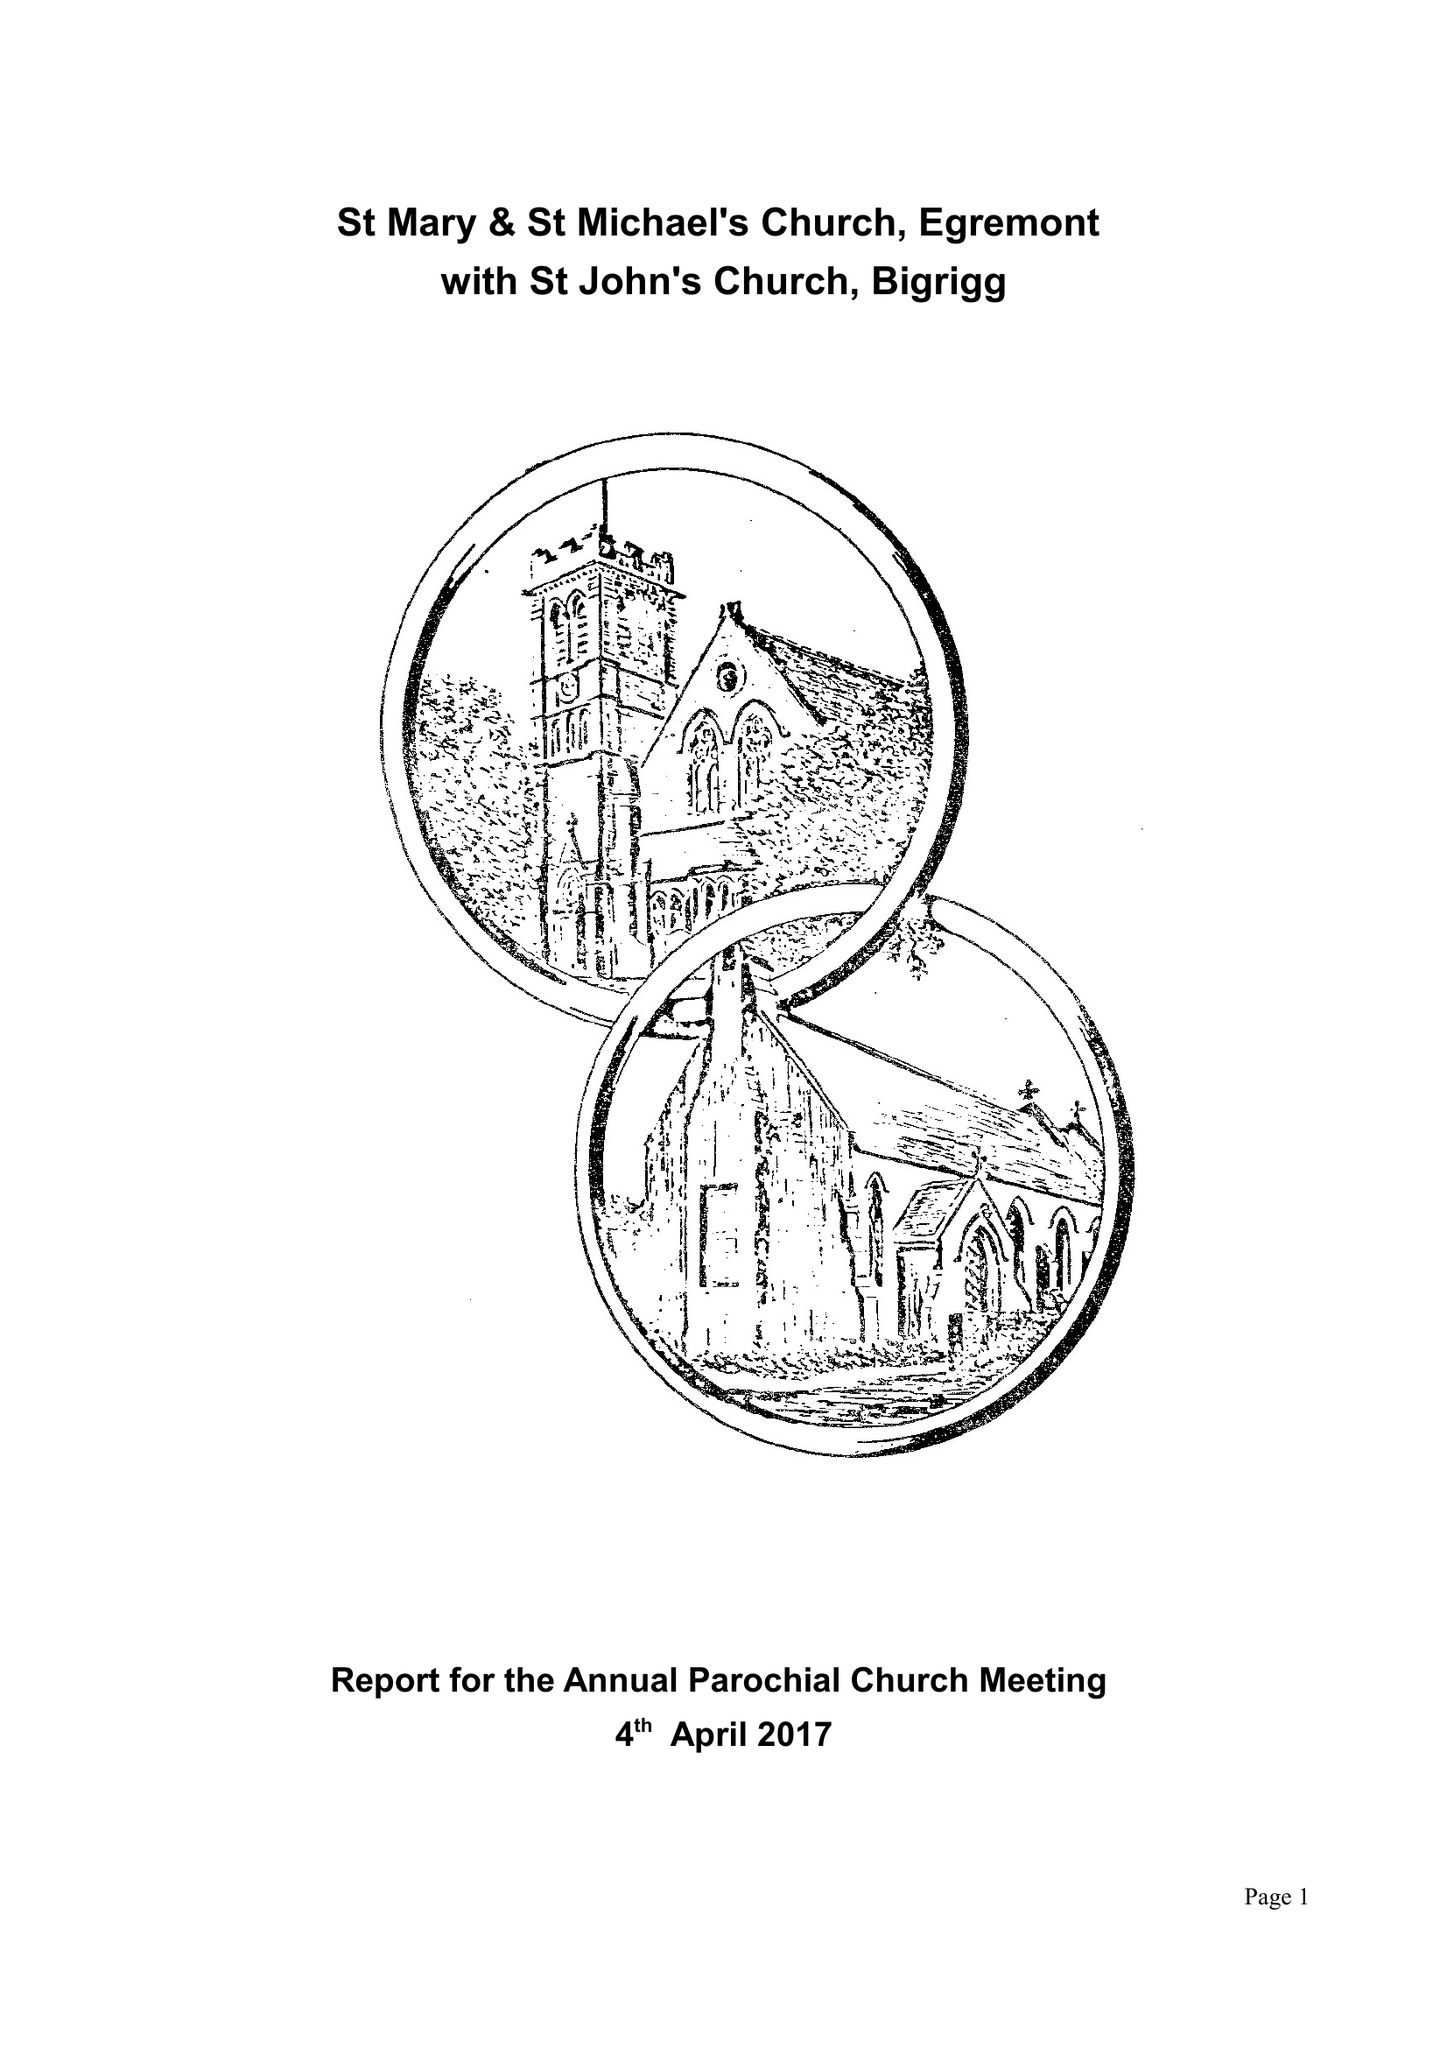What is the value for the spending_annually_in_british_pounds?
Answer the question using a single word or phrase. 98450.00 